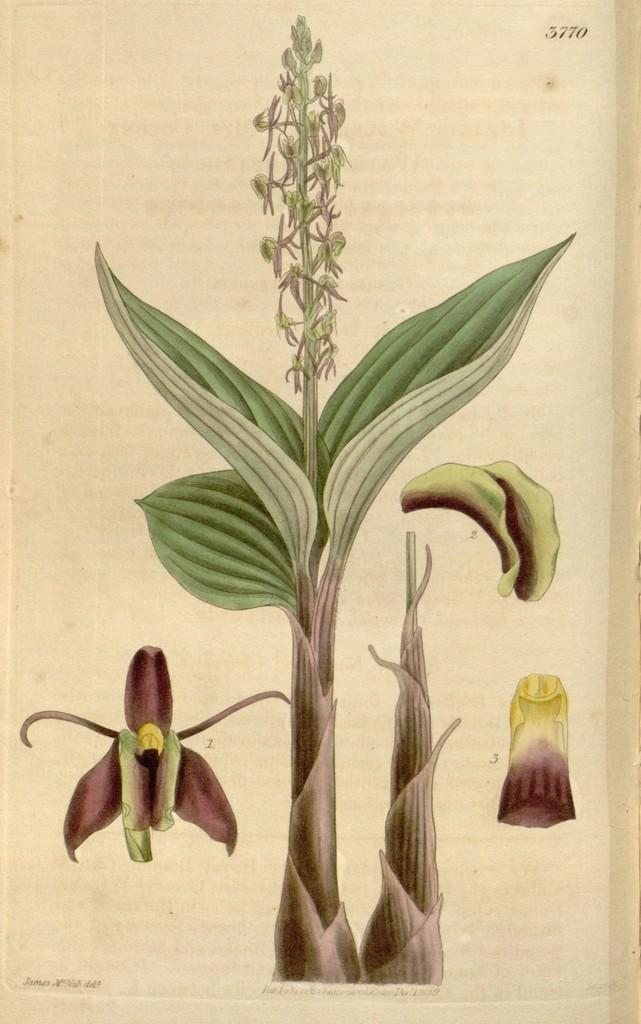What color is the plant in the image? The plant is green. Is there a cast visible on the plant in the image? There is no cast present on the plant in the image, as it is a living organism and not a human or animal. 